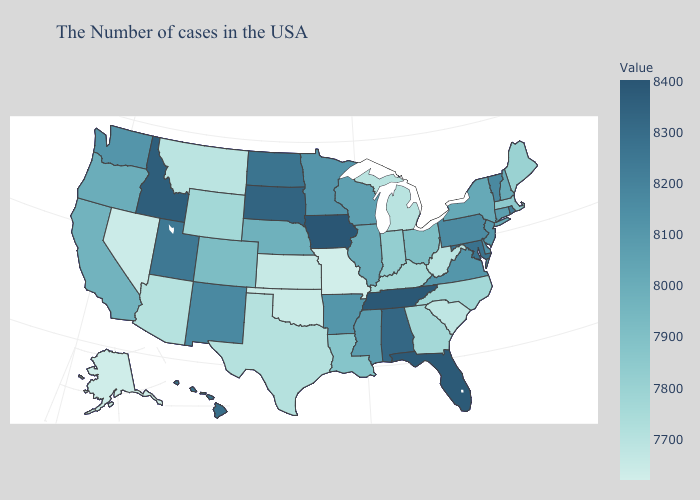Among the states that border Kentucky , which have the highest value?
Write a very short answer. Tennessee. 